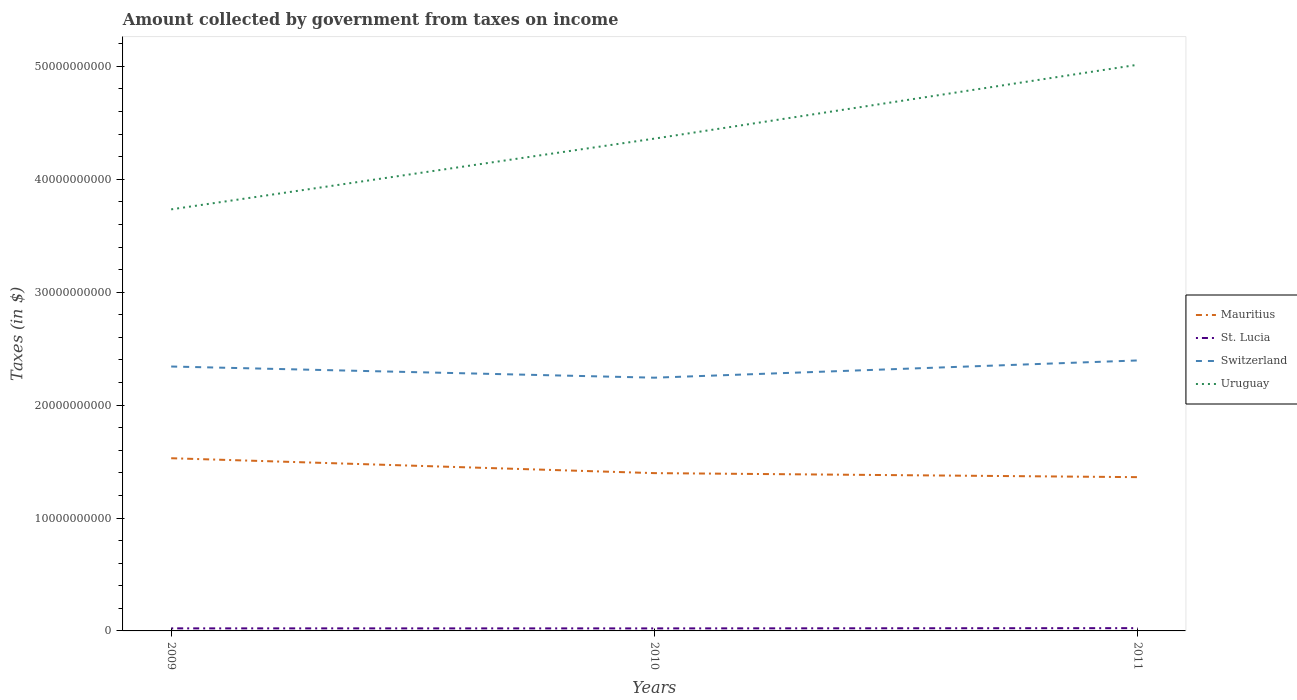Is the number of lines equal to the number of legend labels?
Offer a terse response. Yes. Across all years, what is the maximum amount collected by government from taxes on income in Uruguay?
Offer a terse response. 3.73e+1. In which year was the amount collected by government from taxes on income in Switzerland maximum?
Give a very brief answer. 2010. What is the total amount collected by government from taxes on income in St. Lucia in the graph?
Give a very brief answer. -2.20e+07. What is the difference between the highest and the second highest amount collected by government from taxes on income in Mauritius?
Provide a short and direct response. 1.68e+09. What is the difference between the highest and the lowest amount collected by government from taxes on income in Uruguay?
Give a very brief answer. 1. How many lines are there?
Your answer should be very brief. 4. What is the difference between two consecutive major ticks on the Y-axis?
Your answer should be compact. 1.00e+1. Are the values on the major ticks of Y-axis written in scientific E-notation?
Provide a succinct answer. No. Does the graph contain any zero values?
Offer a terse response. No. Where does the legend appear in the graph?
Keep it short and to the point. Center right. What is the title of the graph?
Ensure brevity in your answer.  Amount collected by government from taxes on income. Does "United Kingdom" appear as one of the legend labels in the graph?
Your response must be concise. No. What is the label or title of the X-axis?
Make the answer very short. Years. What is the label or title of the Y-axis?
Make the answer very short. Taxes (in $). What is the Taxes (in $) of Mauritius in 2009?
Your response must be concise. 1.53e+1. What is the Taxes (in $) in St. Lucia in 2009?
Your answer should be very brief. 2.26e+08. What is the Taxes (in $) in Switzerland in 2009?
Offer a very short reply. 2.34e+1. What is the Taxes (in $) of Uruguay in 2009?
Ensure brevity in your answer.  3.73e+1. What is the Taxes (in $) of Mauritius in 2010?
Provide a short and direct response. 1.40e+1. What is the Taxes (in $) of St. Lucia in 2010?
Provide a succinct answer. 2.23e+08. What is the Taxes (in $) of Switzerland in 2010?
Provide a succinct answer. 2.24e+1. What is the Taxes (in $) in Uruguay in 2010?
Keep it short and to the point. 4.36e+1. What is the Taxes (in $) in Mauritius in 2011?
Keep it short and to the point. 1.36e+1. What is the Taxes (in $) in St. Lucia in 2011?
Your response must be concise. 2.45e+08. What is the Taxes (in $) in Switzerland in 2011?
Provide a succinct answer. 2.40e+1. What is the Taxes (in $) in Uruguay in 2011?
Offer a terse response. 5.01e+1. Across all years, what is the maximum Taxes (in $) in Mauritius?
Offer a terse response. 1.53e+1. Across all years, what is the maximum Taxes (in $) in St. Lucia?
Ensure brevity in your answer.  2.45e+08. Across all years, what is the maximum Taxes (in $) in Switzerland?
Give a very brief answer. 2.40e+1. Across all years, what is the maximum Taxes (in $) of Uruguay?
Your answer should be very brief. 5.01e+1. Across all years, what is the minimum Taxes (in $) of Mauritius?
Provide a short and direct response. 1.36e+1. Across all years, what is the minimum Taxes (in $) of St. Lucia?
Offer a very short reply. 2.23e+08. Across all years, what is the minimum Taxes (in $) in Switzerland?
Your answer should be compact. 2.24e+1. Across all years, what is the minimum Taxes (in $) in Uruguay?
Your answer should be compact. 3.73e+1. What is the total Taxes (in $) of Mauritius in the graph?
Offer a terse response. 4.29e+1. What is the total Taxes (in $) in St. Lucia in the graph?
Make the answer very short. 6.95e+08. What is the total Taxes (in $) of Switzerland in the graph?
Offer a terse response. 6.98e+1. What is the total Taxes (in $) of Uruguay in the graph?
Keep it short and to the point. 1.31e+11. What is the difference between the Taxes (in $) in Mauritius in 2009 and that in 2010?
Offer a terse response. 1.32e+09. What is the difference between the Taxes (in $) of St. Lucia in 2009 and that in 2010?
Offer a terse response. 3.10e+06. What is the difference between the Taxes (in $) of Switzerland in 2009 and that in 2010?
Your answer should be very brief. 9.90e+08. What is the difference between the Taxes (in $) of Uruguay in 2009 and that in 2010?
Keep it short and to the point. -6.27e+09. What is the difference between the Taxes (in $) in Mauritius in 2009 and that in 2011?
Ensure brevity in your answer.  1.68e+09. What is the difference between the Taxes (in $) of St. Lucia in 2009 and that in 2011?
Make the answer very short. -1.89e+07. What is the difference between the Taxes (in $) of Switzerland in 2009 and that in 2011?
Give a very brief answer. -5.37e+08. What is the difference between the Taxes (in $) in Uruguay in 2009 and that in 2011?
Provide a succinct answer. -1.28e+1. What is the difference between the Taxes (in $) of Mauritius in 2010 and that in 2011?
Provide a succinct answer. 3.57e+08. What is the difference between the Taxes (in $) of St. Lucia in 2010 and that in 2011?
Provide a short and direct response. -2.20e+07. What is the difference between the Taxes (in $) of Switzerland in 2010 and that in 2011?
Give a very brief answer. -1.53e+09. What is the difference between the Taxes (in $) in Uruguay in 2010 and that in 2011?
Offer a terse response. -6.54e+09. What is the difference between the Taxes (in $) of Mauritius in 2009 and the Taxes (in $) of St. Lucia in 2010?
Give a very brief answer. 1.51e+1. What is the difference between the Taxes (in $) in Mauritius in 2009 and the Taxes (in $) in Switzerland in 2010?
Your answer should be very brief. -7.13e+09. What is the difference between the Taxes (in $) of Mauritius in 2009 and the Taxes (in $) of Uruguay in 2010?
Give a very brief answer. -2.83e+1. What is the difference between the Taxes (in $) in St. Lucia in 2009 and the Taxes (in $) in Switzerland in 2010?
Your answer should be very brief. -2.22e+1. What is the difference between the Taxes (in $) in St. Lucia in 2009 and the Taxes (in $) in Uruguay in 2010?
Give a very brief answer. -4.34e+1. What is the difference between the Taxes (in $) in Switzerland in 2009 and the Taxes (in $) in Uruguay in 2010?
Your response must be concise. -2.02e+1. What is the difference between the Taxes (in $) in Mauritius in 2009 and the Taxes (in $) in St. Lucia in 2011?
Provide a succinct answer. 1.51e+1. What is the difference between the Taxes (in $) of Mauritius in 2009 and the Taxes (in $) of Switzerland in 2011?
Your answer should be very brief. -8.66e+09. What is the difference between the Taxes (in $) in Mauritius in 2009 and the Taxes (in $) in Uruguay in 2011?
Provide a succinct answer. -3.49e+1. What is the difference between the Taxes (in $) of St. Lucia in 2009 and the Taxes (in $) of Switzerland in 2011?
Your answer should be very brief. -2.37e+1. What is the difference between the Taxes (in $) in St. Lucia in 2009 and the Taxes (in $) in Uruguay in 2011?
Provide a succinct answer. -4.99e+1. What is the difference between the Taxes (in $) in Switzerland in 2009 and the Taxes (in $) in Uruguay in 2011?
Offer a very short reply. -2.67e+1. What is the difference between the Taxes (in $) of Mauritius in 2010 and the Taxes (in $) of St. Lucia in 2011?
Keep it short and to the point. 1.37e+1. What is the difference between the Taxes (in $) of Mauritius in 2010 and the Taxes (in $) of Switzerland in 2011?
Keep it short and to the point. -9.98e+09. What is the difference between the Taxes (in $) in Mauritius in 2010 and the Taxes (in $) in Uruguay in 2011?
Give a very brief answer. -3.62e+1. What is the difference between the Taxes (in $) of St. Lucia in 2010 and the Taxes (in $) of Switzerland in 2011?
Provide a succinct answer. -2.37e+1. What is the difference between the Taxes (in $) in St. Lucia in 2010 and the Taxes (in $) in Uruguay in 2011?
Offer a very short reply. -4.99e+1. What is the difference between the Taxes (in $) of Switzerland in 2010 and the Taxes (in $) of Uruguay in 2011?
Ensure brevity in your answer.  -2.77e+1. What is the average Taxes (in $) in Mauritius per year?
Keep it short and to the point. 1.43e+1. What is the average Taxes (in $) in St. Lucia per year?
Provide a succinct answer. 2.32e+08. What is the average Taxes (in $) of Switzerland per year?
Provide a short and direct response. 2.33e+1. What is the average Taxes (in $) in Uruguay per year?
Your answer should be very brief. 4.37e+1. In the year 2009, what is the difference between the Taxes (in $) of Mauritius and Taxes (in $) of St. Lucia?
Give a very brief answer. 1.51e+1. In the year 2009, what is the difference between the Taxes (in $) of Mauritius and Taxes (in $) of Switzerland?
Your response must be concise. -8.12e+09. In the year 2009, what is the difference between the Taxes (in $) of Mauritius and Taxes (in $) of Uruguay?
Offer a very short reply. -2.20e+1. In the year 2009, what is the difference between the Taxes (in $) in St. Lucia and Taxes (in $) in Switzerland?
Provide a short and direct response. -2.32e+1. In the year 2009, what is the difference between the Taxes (in $) in St. Lucia and Taxes (in $) in Uruguay?
Keep it short and to the point. -3.71e+1. In the year 2009, what is the difference between the Taxes (in $) of Switzerland and Taxes (in $) of Uruguay?
Give a very brief answer. -1.39e+1. In the year 2010, what is the difference between the Taxes (in $) in Mauritius and Taxes (in $) in St. Lucia?
Your answer should be very brief. 1.38e+1. In the year 2010, what is the difference between the Taxes (in $) of Mauritius and Taxes (in $) of Switzerland?
Make the answer very short. -8.45e+09. In the year 2010, what is the difference between the Taxes (in $) in Mauritius and Taxes (in $) in Uruguay?
Ensure brevity in your answer.  -2.96e+1. In the year 2010, what is the difference between the Taxes (in $) of St. Lucia and Taxes (in $) of Switzerland?
Give a very brief answer. -2.22e+1. In the year 2010, what is the difference between the Taxes (in $) in St. Lucia and Taxes (in $) in Uruguay?
Give a very brief answer. -4.34e+1. In the year 2010, what is the difference between the Taxes (in $) in Switzerland and Taxes (in $) in Uruguay?
Your answer should be compact. -2.12e+1. In the year 2011, what is the difference between the Taxes (in $) in Mauritius and Taxes (in $) in St. Lucia?
Your response must be concise. 1.34e+1. In the year 2011, what is the difference between the Taxes (in $) in Mauritius and Taxes (in $) in Switzerland?
Provide a succinct answer. -1.03e+1. In the year 2011, what is the difference between the Taxes (in $) in Mauritius and Taxes (in $) in Uruguay?
Give a very brief answer. -3.65e+1. In the year 2011, what is the difference between the Taxes (in $) in St. Lucia and Taxes (in $) in Switzerland?
Provide a succinct answer. -2.37e+1. In the year 2011, what is the difference between the Taxes (in $) in St. Lucia and Taxes (in $) in Uruguay?
Ensure brevity in your answer.  -4.99e+1. In the year 2011, what is the difference between the Taxes (in $) in Switzerland and Taxes (in $) in Uruguay?
Give a very brief answer. -2.62e+1. What is the ratio of the Taxes (in $) in Mauritius in 2009 to that in 2010?
Provide a succinct answer. 1.09. What is the ratio of the Taxes (in $) in St. Lucia in 2009 to that in 2010?
Keep it short and to the point. 1.01. What is the ratio of the Taxes (in $) in Switzerland in 2009 to that in 2010?
Your response must be concise. 1.04. What is the ratio of the Taxes (in $) of Uruguay in 2009 to that in 2010?
Your answer should be compact. 0.86. What is the ratio of the Taxes (in $) of Mauritius in 2009 to that in 2011?
Your response must be concise. 1.12. What is the ratio of the Taxes (in $) of St. Lucia in 2009 to that in 2011?
Offer a very short reply. 0.92. What is the ratio of the Taxes (in $) of Switzerland in 2009 to that in 2011?
Make the answer very short. 0.98. What is the ratio of the Taxes (in $) in Uruguay in 2009 to that in 2011?
Ensure brevity in your answer.  0.74. What is the ratio of the Taxes (in $) in Mauritius in 2010 to that in 2011?
Offer a very short reply. 1.03. What is the ratio of the Taxes (in $) in St. Lucia in 2010 to that in 2011?
Make the answer very short. 0.91. What is the ratio of the Taxes (in $) of Switzerland in 2010 to that in 2011?
Give a very brief answer. 0.94. What is the ratio of the Taxes (in $) in Uruguay in 2010 to that in 2011?
Offer a very short reply. 0.87. What is the difference between the highest and the second highest Taxes (in $) in Mauritius?
Provide a succinct answer. 1.32e+09. What is the difference between the highest and the second highest Taxes (in $) in St. Lucia?
Provide a succinct answer. 1.89e+07. What is the difference between the highest and the second highest Taxes (in $) of Switzerland?
Your answer should be very brief. 5.37e+08. What is the difference between the highest and the second highest Taxes (in $) of Uruguay?
Your answer should be very brief. 6.54e+09. What is the difference between the highest and the lowest Taxes (in $) in Mauritius?
Offer a terse response. 1.68e+09. What is the difference between the highest and the lowest Taxes (in $) in St. Lucia?
Give a very brief answer. 2.20e+07. What is the difference between the highest and the lowest Taxes (in $) of Switzerland?
Give a very brief answer. 1.53e+09. What is the difference between the highest and the lowest Taxes (in $) in Uruguay?
Your answer should be compact. 1.28e+1. 